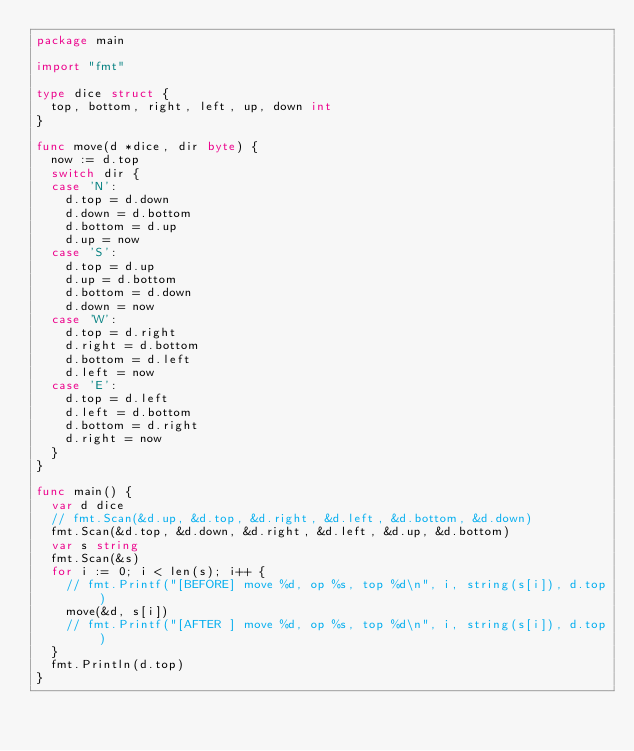<code> <loc_0><loc_0><loc_500><loc_500><_Go_>package main

import "fmt"

type dice struct {
	top, bottom, right, left, up, down int
}

func move(d *dice, dir byte) {
	now := d.top
	switch dir {
	case 'N':
		d.top = d.down
		d.down = d.bottom
		d.bottom = d.up
		d.up = now
	case 'S':
		d.top = d.up
		d.up = d.bottom
		d.bottom = d.down
		d.down = now
	case 'W':
		d.top = d.right
		d.right = d.bottom
		d.bottom = d.left
		d.left = now
	case 'E':
		d.top = d.left
		d.left = d.bottom
		d.bottom = d.right
		d.right = now
	}
}

func main() {
	var d dice
	// fmt.Scan(&d.up, &d.top, &d.right, &d.left, &d.bottom, &d.down)
	fmt.Scan(&d.top, &d.down, &d.right, &d.left, &d.up, &d.bottom)
	var s string
	fmt.Scan(&s)
	for i := 0; i < len(s); i++ {
		// fmt.Printf("[BEFORE] move %d, op %s, top %d\n", i, string(s[i]), d.top)
		move(&d, s[i])
		// fmt.Printf("[AFTER ] move %d, op %s, top %d\n", i, string(s[i]), d.top)
	}
	fmt.Println(d.top)
}

</code> 